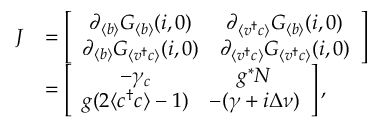<formula> <loc_0><loc_0><loc_500><loc_500>\begin{array} { r l } { J } & { = \left [ \begin{array} { c c } { \partial _ { \langle b \rangle } G _ { \langle b \rangle } ( { i } , 0 ) } & { \partial _ { \langle v ^ { \dagger } c \rangle } G _ { \langle b \rangle } ( { i } , 0 ) } \\ { \partial _ { \langle b \rangle } G _ { \langle v ^ { \dagger } c \rangle } ( { i } , 0 ) } & { \partial _ { \langle v ^ { \dagger } c \rangle } G _ { \langle v ^ { \dagger } c \rangle } ( { i } , 0 ) } \end{array} \right ] } \\ & { = \left [ \begin{array} { c c } { - \gamma _ { c } } & { g ^ { * } N } \\ { g ( 2 \langle c ^ { \dagger } c \rangle - 1 ) } & { - ( \gamma + i \Delta \nu ) } \end{array} \right ] , } \end{array}</formula> 